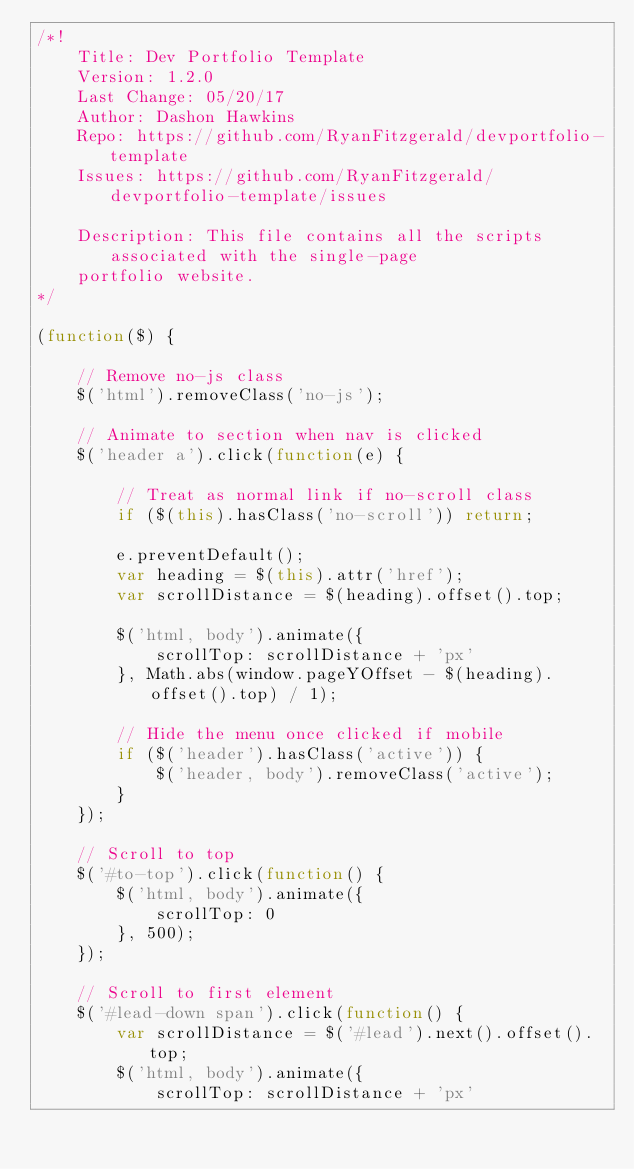<code> <loc_0><loc_0><loc_500><loc_500><_JavaScript_>/*!
    Title: Dev Portfolio Template
    Version: 1.2.0
    Last Change: 05/20/17
    Author: Dashon Hawkins
    Repo: https://github.com/RyanFitzgerald/devportfolio-template
    Issues: https://github.com/RyanFitzgerald/devportfolio-template/issues

    Description: This file contains all the scripts associated with the single-page
    portfolio website.
*/

(function($) {

    // Remove no-js class
    $('html').removeClass('no-js');

    // Animate to section when nav is clicked
    $('header a').click(function(e) {

        // Treat as normal link if no-scroll class
        if ($(this).hasClass('no-scroll')) return;

        e.preventDefault();
        var heading = $(this).attr('href');
        var scrollDistance = $(heading).offset().top;

        $('html, body').animate({
            scrollTop: scrollDistance + 'px'
        }, Math.abs(window.pageYOffset - $(heading).offset().top) / 1);

        // Hide the menu once clicked if mobile
        if ($('header').hasClass('active')) {
            $('header, body').removeClass('active');
        }
    });

    // Scroll to top
    $('#to-top').click(function() {
        $('html, body').animate({
            scrollTop: 0
        }, 500);
    });

    // Scroll to first element
    $('#lead-down span').click(function() {
        var scrollDistance = $('#lead').next().offset().top;
        $('html, body').animate({
            scrollTop: scrollDistance + 'px'</code> 